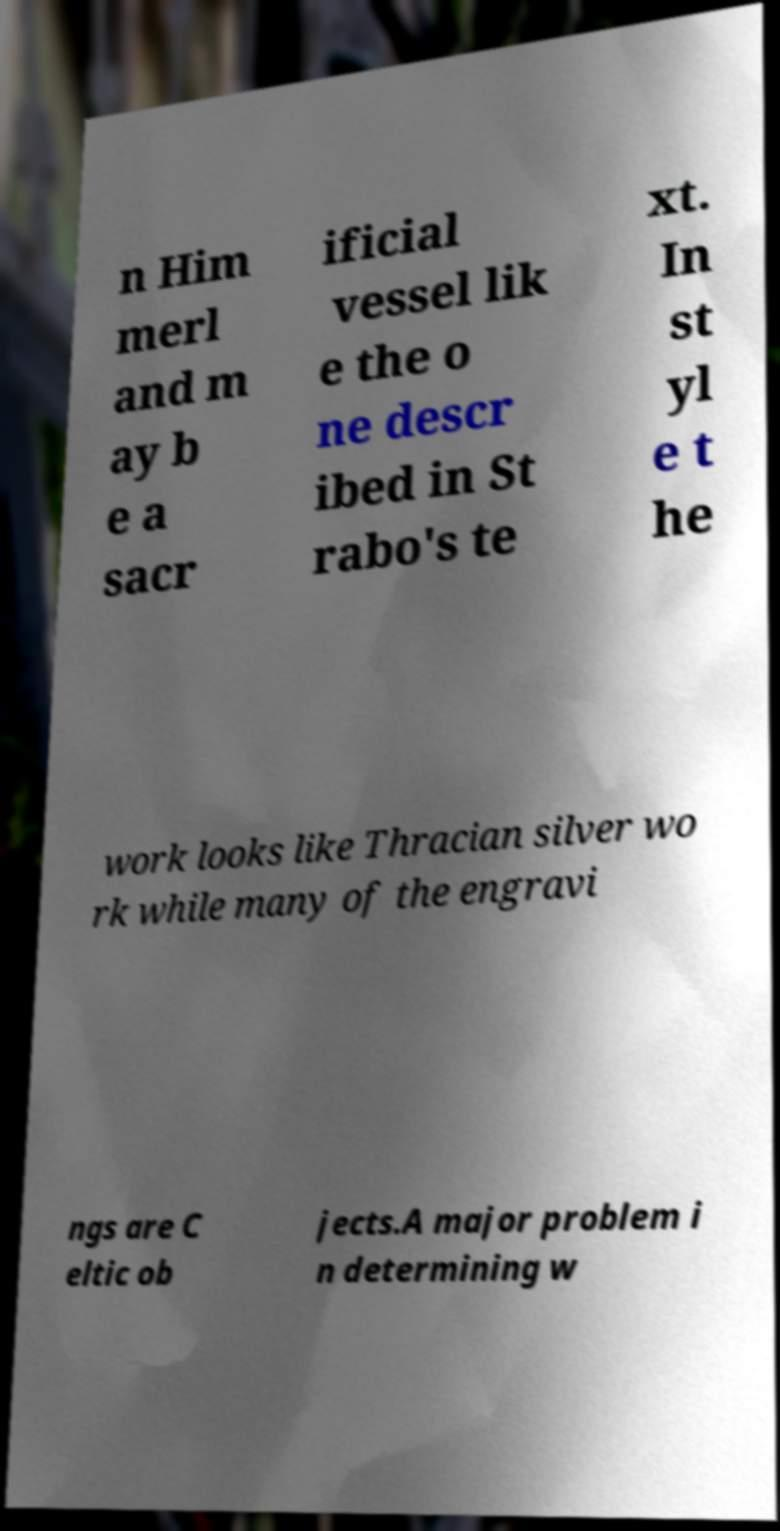Please identify and transcribe the text found in this image. n Him merl and m ay b e a sacr ificial vessel lik e the o ne descr ibed in St rabo's te xt. In st yl e t he work looks like Thracian silver wo rk while many of the engravi ngs are C eltic ob jects.A major problem i n determining w 